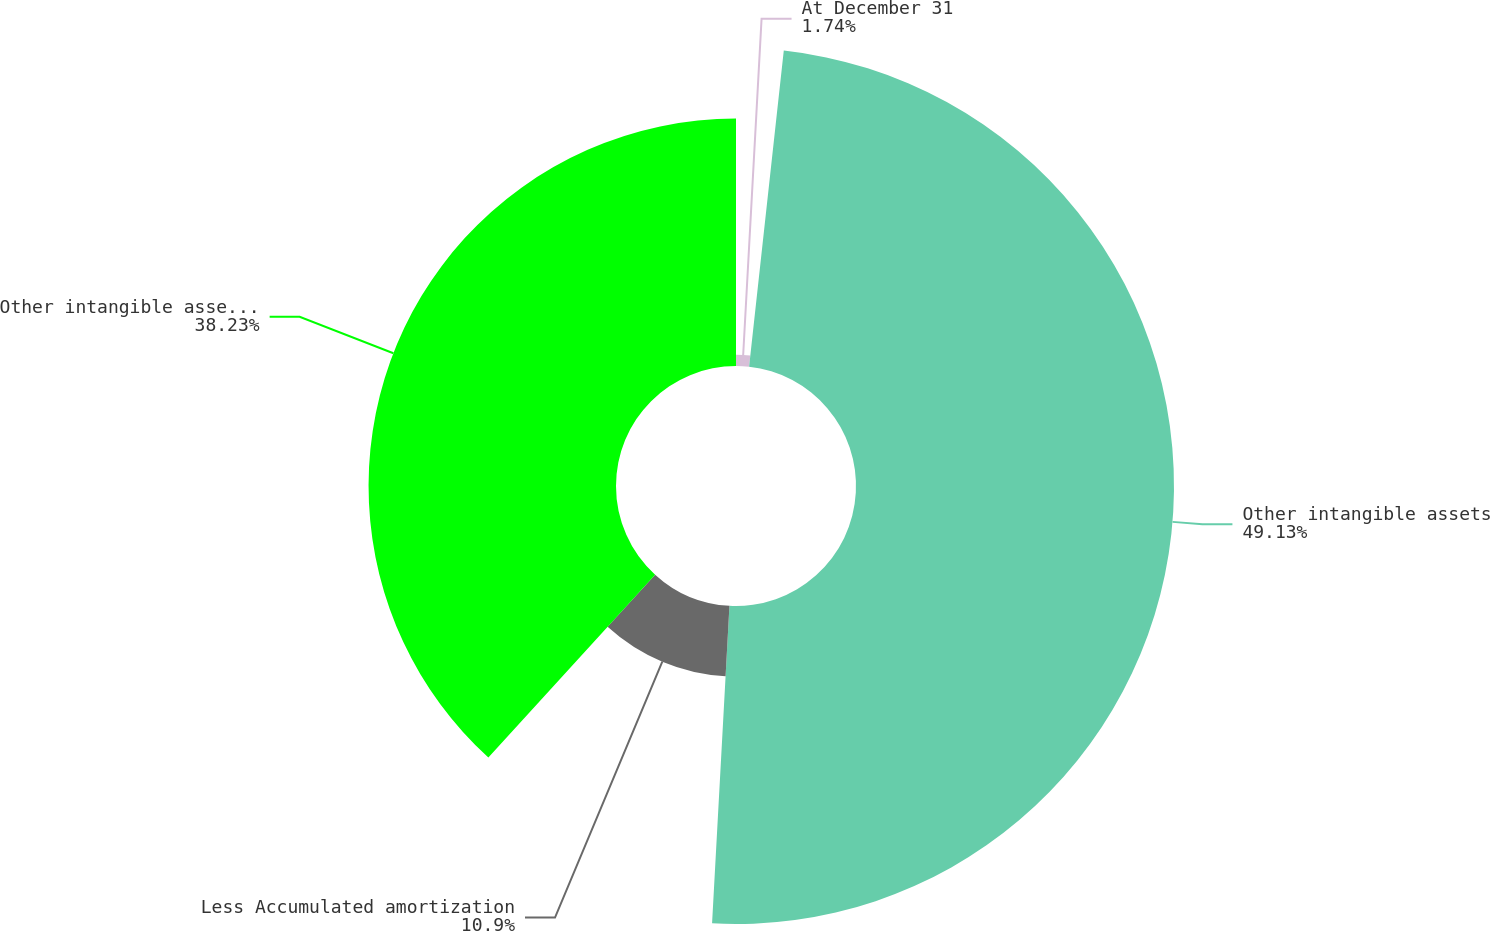Convert chart to OTSL. <chart><loc_0><loc_0><loc_500><loc_500><pie_chart><fcel>At December 31<fcel>Other intangible assets<fcel>Less Accumulated amortization<fcel>Other intangible assets net<nl><fcel>1.74%<fcel>49.13%<fcel>10.9%<fcel>38.23%<nl></chart> 